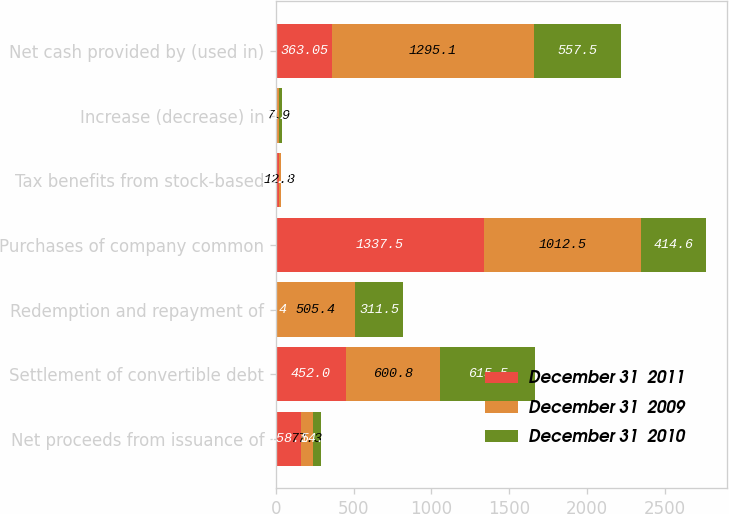Convert chart to OTSL. <chart><loc_0><loc_0><loc_500><loc_500><stacked_bar_chart><ecel><fcel>Net proceeds from issuance of<fcel>Settlement of convertible debt<fcel>Redemption and repayment of<fcel>Purchases of company common<fcel>Tax benefits from stock-based<fcel>Increase (decrease) in<fcel>Net cash provided by (used in)<nl><fcel>December 31  2011<fcel>158.1<fcel>452<fcel>1.4<fcel>1337.5<fcel>16.9<fcel>9.2<fcel>363.05<nl><fcel>December 31  2009<fcel>77.3<fcel>600.8<fcel>505.4<fcel>1012.5<fcel>12.8<fcel>7.9<fcel>1295.1<nl><fcel>December 31  2010<fcel>54.4<fcel>615.5<fcel>311.5<fcel>414.6<fcel>2.6<fcel>21.1<fcel>557.5<nl></chart> 